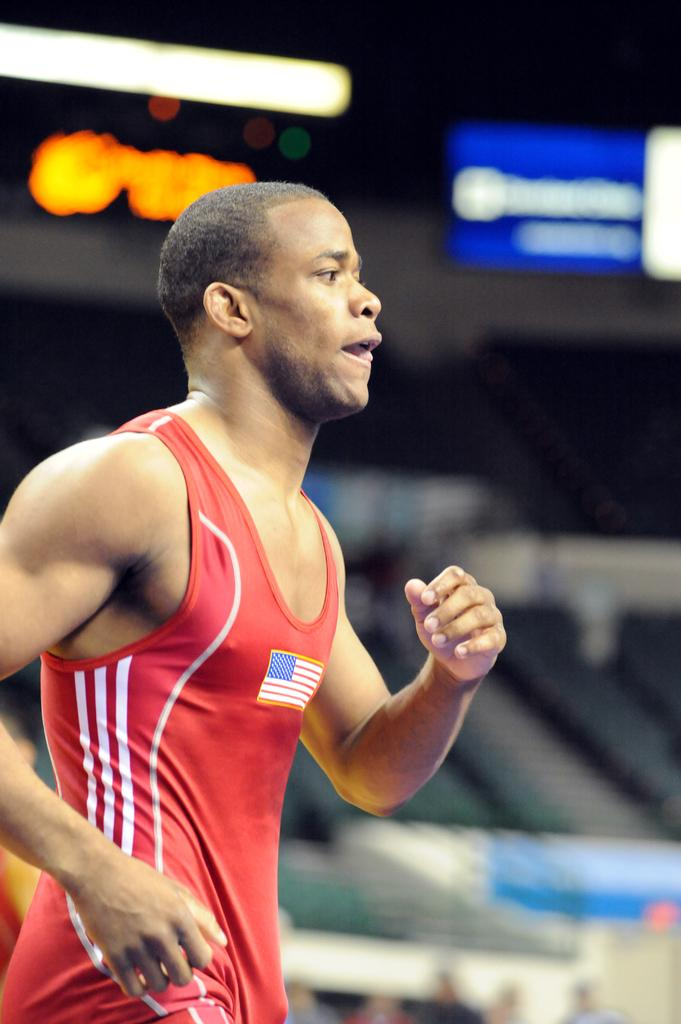Who is in the image? There is a person in the image. What is the person wearing? The person is wearing a red t-shirt. What is the person doing in the image? The person is running. Can you describe the background of the image? The background of the image is blurred. What type of breakfast is the person eating in the image? There is no breakfast present in the image; the person is running. What rule is being enforced in the image? There is no rule being enforced in the image; it simply shows a person running. 